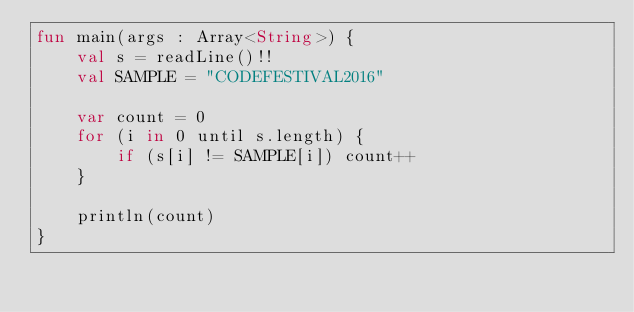<code> <loc_0><loc_0><loc_500><loc_500><_Kotlin_>fun main(args : Array<String>) {
    val s = readLine()!!
    val SAMPLE = "CODEFESTIVAL2016"

    var count = 0
    for (i in 0 until s.length) {
        if (s[i] != SAMPLE[i]) count++
    }

    println(count)
}</code> 